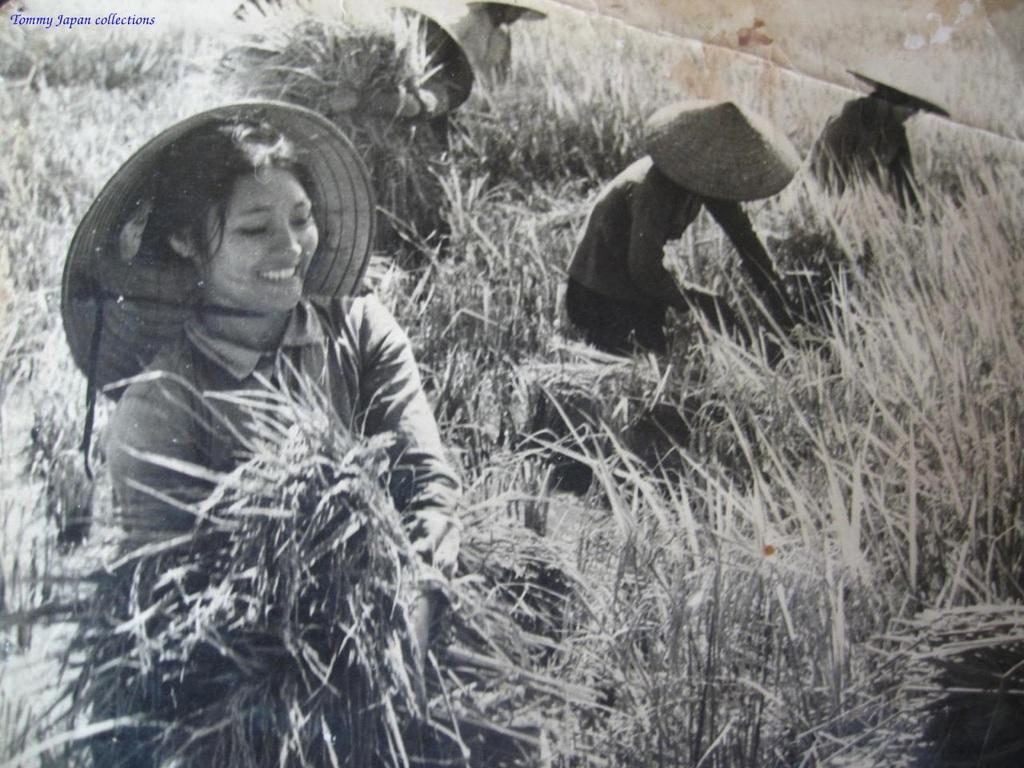What is happening in the image involving a group of people? In the image, there is a group of people standing and holding grass. What can be seen at the bottom of the image? There is grass at the bottom of the image. Is there any text present in the image? Yes, there is text at the top left of the image. What type of quiet environment is depicted in the image? The image does not depict a quiet environment, as there is a group of people standing and holding grass. What tools might a carpenter use in the image? There are no carpentry tools or a carpenter present in the image. 